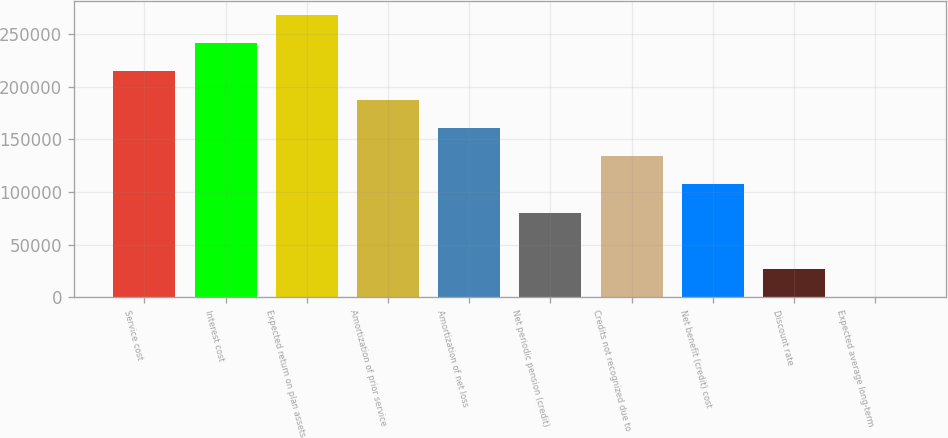Convert chart to OTSL. <chart><loc_0><loc_0><loc_500><loc_500><bar_chart><fcel>Service cost<fcel>Interest cost<fcel>Expected return on plan assets<fcel>Amortization of prior service<fcel>Amortization of net loss<fcel>Net periodic pension (credit)<fcel>Credits not recognized due to<fcel>Net benefit (credit) cost<fcel>Discount rate<fcel>Expected average long-term<nl><fcel>214453<fcel>241259<fcel>268065<fcel>187647<fcel>160840<fcel>80421.9<fcel>134034<fcel>107228<fcel>26809.7<fcel>3.5<nl></chart> 